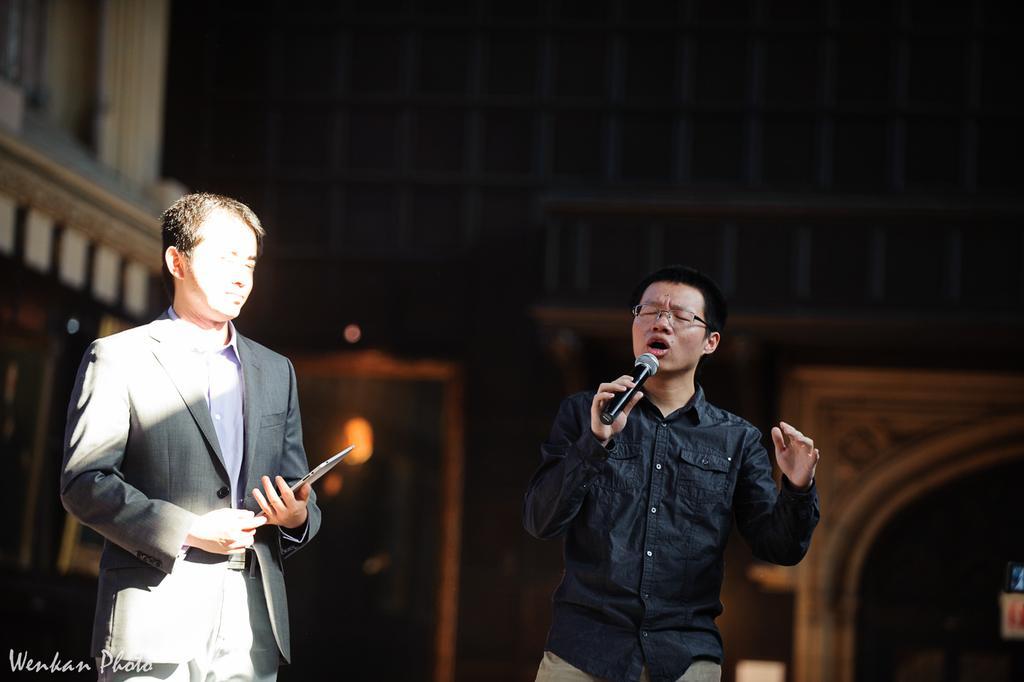In one or two sentences, can you explain what this image depicts? In this image in the left the man is singing as his mouth is open. He is holding a mic. Beside him a man is holding a tablet. He is wearing a suit. In the background there is building. 